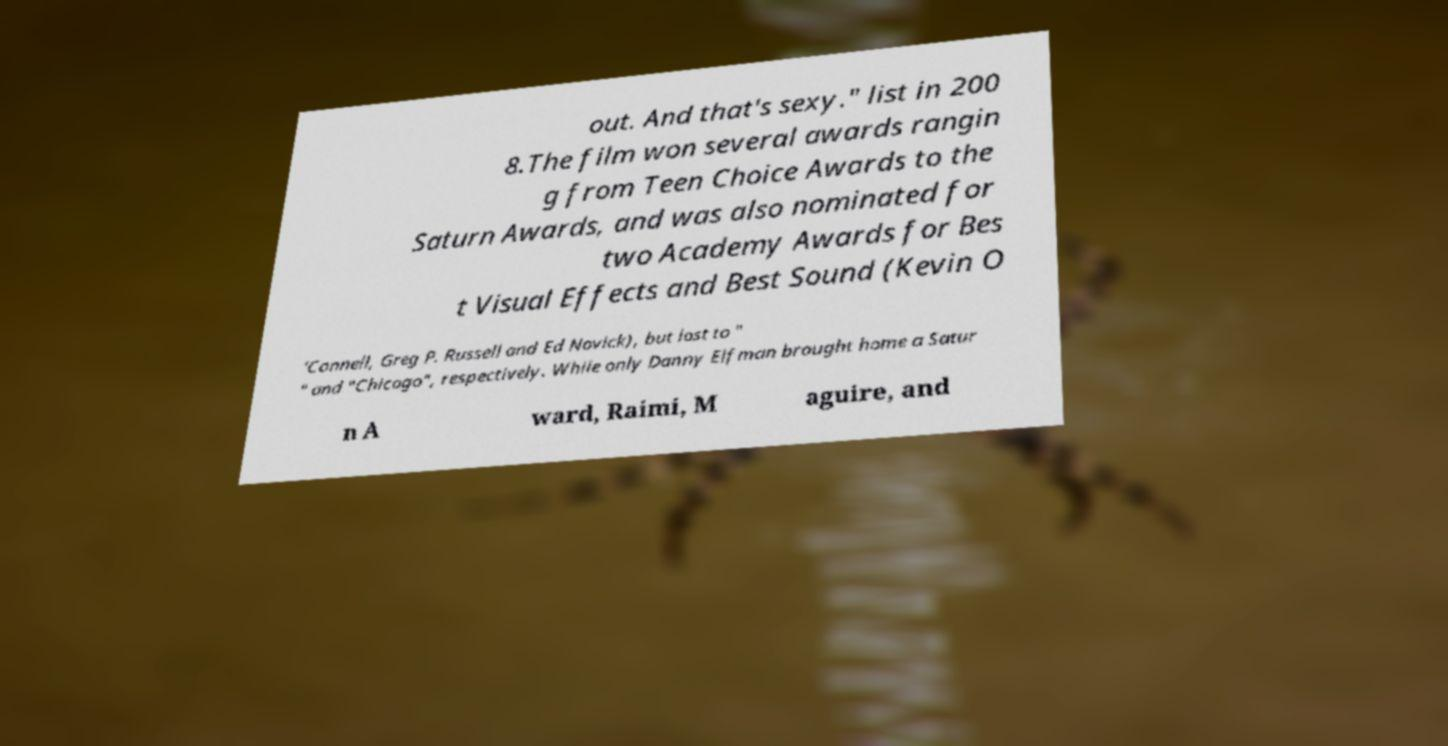Could you extract and type out the text from this image? out. And that's sexy." list in 200 8.The film won several awards rangin g from Teen Choice Awards to the Saturn Awards, and was also nominated for two Academy Awards for Bes t Visual Effects and Best Sound (Kevin O 'Connell, Greg P. Russell and Ed Novick), but lost to " " and "Chicago", respectively. While only Danny Elfman brought home a Satur n A ward, Raimi, M aguire, and 